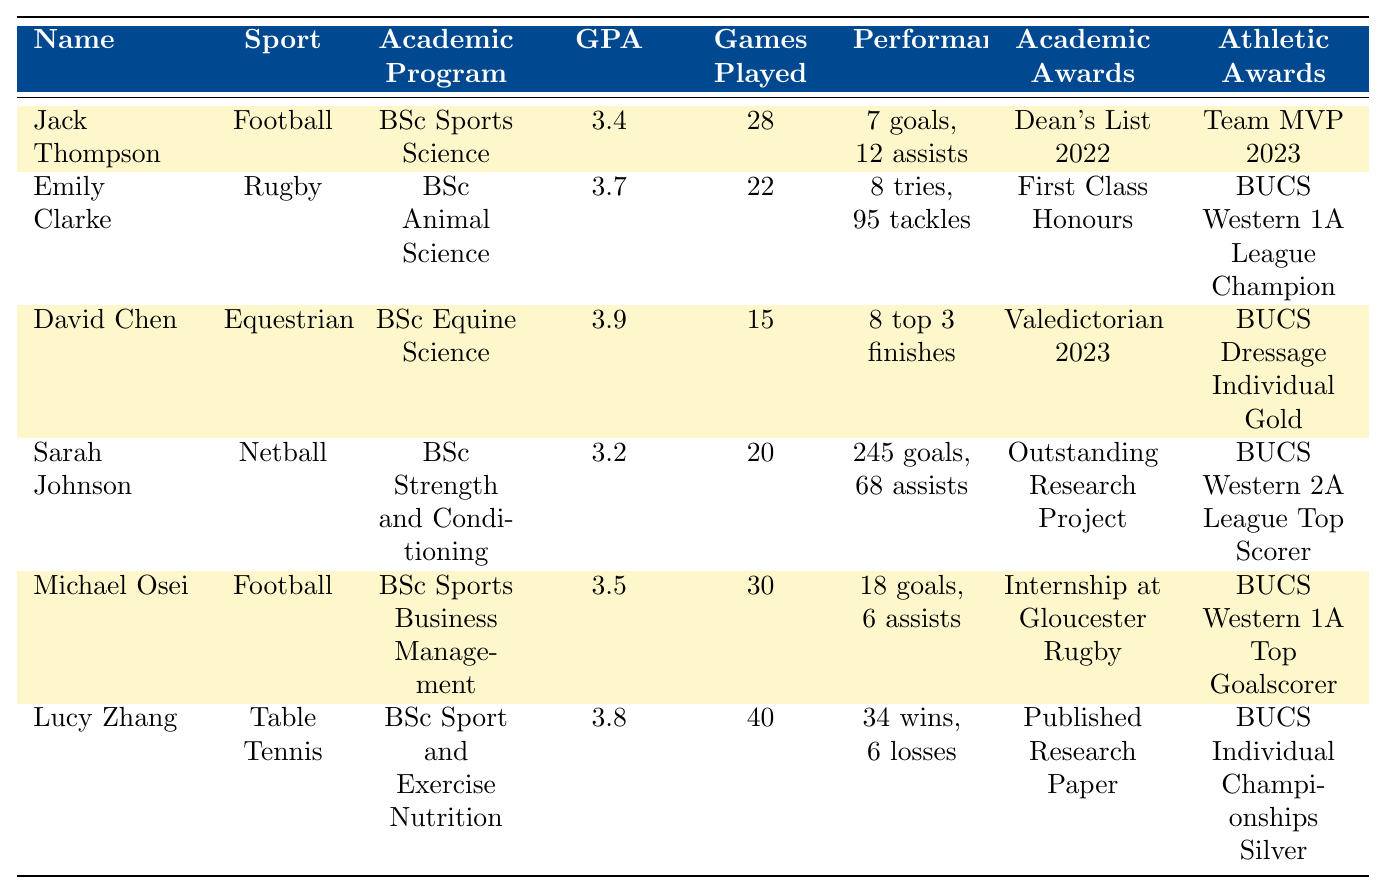What is the GPA of Emily Clarke? Emily Clarke's GPA is listed in the table under her profile. It shows a GPA of 3.7.
Answer: 3.7 Who scored the most goals among the student-athletes? To determine the highest goal scorer, we compare the "Goals Scored" column. Sarah Johnson scored 245 goals, which is more than anyone else.
Answer: Sarah Johnson Which student-athlete has the highest GPA? The GPAs of all student-athletes are examined. David Chen has the highest GPA of 3.9.
Answer: David Chen How many assists did Jack Thompson have? Jack Thompson's assists can be found in the table, listed as 12 assists.
Answer: 12 What is the average GPA of the student-athletes? The GPAs of the student-athletes are summed up (3.4 + 3.7 + 3.9 + 3.2 + 3.5 + 3.8 = 21.5) and divided by 6 (the number of student-athletes) to find the average, which is 21.5 / 6 ≈ 3.58.
Answer: 3.58 Did Lucy Zhang compete in more matches than David Chen? Lucy Zhang played 40 matches while David Chen entered 15 competitions. Since 40 is greater than 15, the statement is true.
Answer: Yes What was the total number of goals scored by Michael Osei and Jack Thompson combined? Michael Osei scored 18 goals and Jack Thompson scored 7 goals; adding these together (18 + 7 = 25) gives a total of 25 goals.
Answer: 25 Which academic program is associated with the student-athlete who has the title "Team MVP 2023"? The title "Team MVP 2023" is associated with Jack Thompson, who is enrolled in the BSc Sports Science academic program.
Answer: BSc Sports Science How many tries did Emily Clarke score? Emily Clarke's tries are listed in the table as 8.
Answer: 8 Who is the only student-athlete who has received the "Valedictorian 2023" award? The award "Valedictorian 2023" is given to David Chen as stated in the table under his academic awards.
Answer: David Chen Which student-athlete has the lowest GPA, and what is the value? By comparing GPAs, Sarah Johnson has the lowest GPA of 3.2, as indicated in the table.
Answer: Sarah Johnson; 3.2 